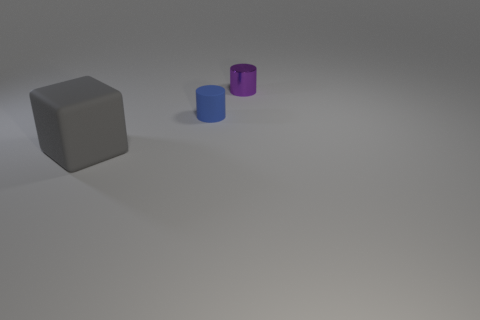Add 3 small blue things. How many objects exist? 6 Subtract all purple cylinders. How many cylinders are left? 1 Subtract all cubes. How many objects are left? 2 Subtract all gray balls. How many purple cylinders are left? 1 Subtract all matte things. Subtract all matte cubes. How many objects are left? 0 Add 2 small purple metallic cylinders. How many small purple metallic cylinders are left? 3 Add 3 tiny cyan rubber cylinders. How many tiny cyan rubber cylinders exist? 3 Subtract 0 red cubes. How many objects are left? 3 Subtract all gray cylinders. Subtract all purple spheres. How many cylinders are left? 2 